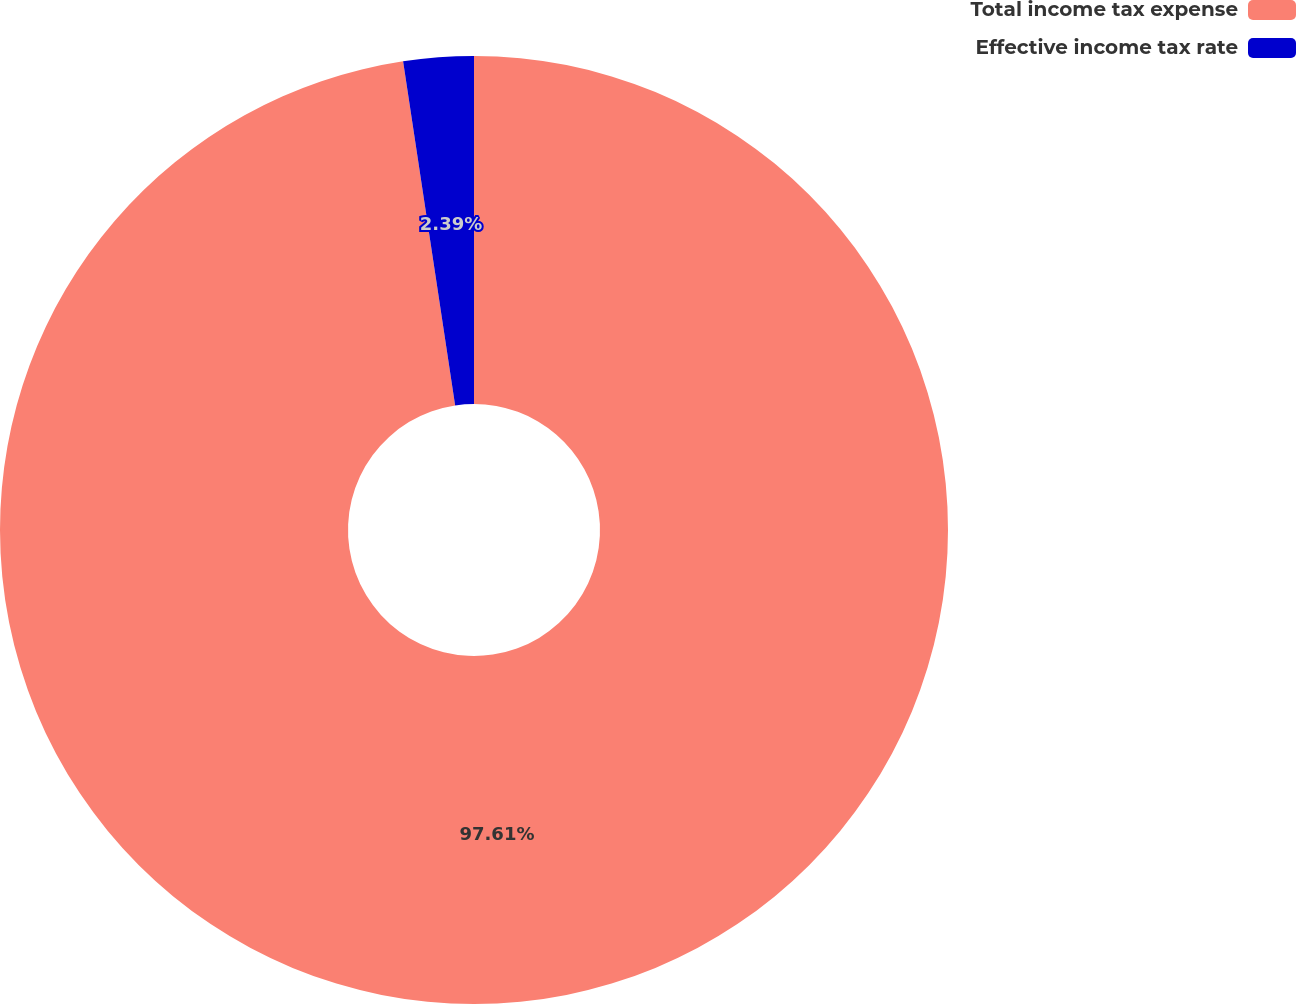<chart> <loc_0><loc_0><loc_500><loc_500><pie_chart><fcel>Total income tax expense<fcel>Effective income tax rate<nl><fcel>97.61%<fcel>2.39%<nl></chart> 